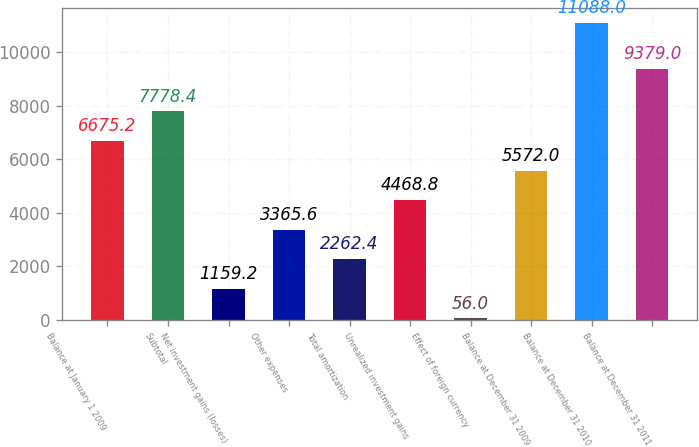<chart> <loc_0><loc_0><loc_500><loc_500><bar_chart><fcel>Balance at January 1 2009<fcel>Subtotal<fcel>Net investment gains (losses)<fcel>Other expenses<fcel>Total amortization<fcel>Unrealized investment gains<fcel>Effect of foreign currency<fcel>Balance at December 31 2009<fcel>Balance at December 31 2010<fcel>Balance at December 31 2011<nl><fcel>6675.2<fcel>7778.4<fcel>1159.2<fcel>3365.6<fcel>2262.4<fcel>4468.8<fcel>56<fcel>5572<fcel>11088<fcel>9379<nl></chart> 